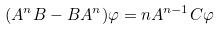Convert formula to latex. <formula><loc_0><loc_0><loc_500><loc_500>( A ^ { n } B - B A ^ { n } ) \varphi = n A ^ { n - 1 } C \varphi</formula> 